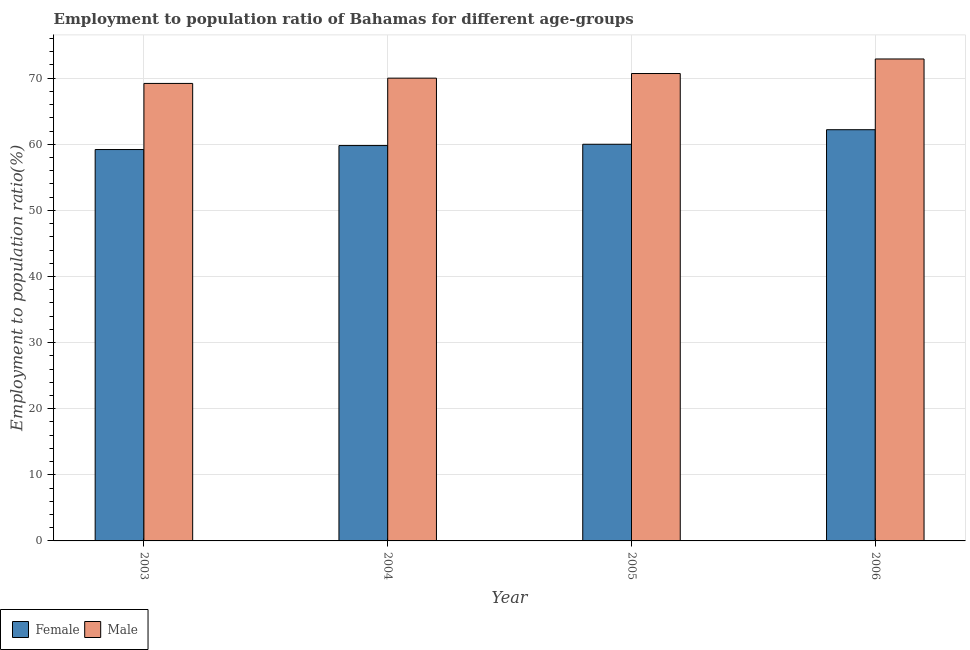Are the number of bars per tick equal to the number of legend labels?
Keep it short and to the point. Yes. Are the number of bars on each tick of the X-axis equal?
Provide a short and direct response. Yes. How many bars are there on the 3rd tick from the left?
Your response must be concise. 2. How many bars are there on the 1st tick from the right?
Provide a short and direct response. 2. What is the employment to population ratio(female) in 2004?
Your answer should be very brief. 59.8. Across all years, what is the maximum employment to population ratio(male)?
Offer a terse response. 72.9. Across all years, what is the minimum employment to population ratio(male)?
Make the answer very short. 69.2. What is the total employment to population ratio(female) in the graph?
Keep it short and to the point. 241.2. What is the difference between the employment to population ratio(female) in 2004 and that in 2005?
Ensure brevity in your answer.  -0.2. What is the difference between the employment to population ratio(male) in 2004 and the employment to population ratio(female) in 2003?
Give a very brief answer. 0.8. What is the average employment to population ratio(female) per year?
Offer a terse response. 60.3. What is the ratio of the employment to population ratio(male) in 2003 to that in 2004?
Offer a very short reply. 0.99. What is the difference between the highest and the second highest employment to population ratio(male)?
Give a very brief answer. 2.2. What is the difference between the highest and the lowest employment to population ratio(male)?
Ensure brevity in your answer.  3.7. In how many years, is the employment to population ratio(male) greater than the average employment to population ratio(male) taken over all years?
Keep it short and to the point. 1. What does the 1st bar from the left in 2004 represents?
Offer a very short reply. Female. How many years are there in the graph?
Your answer should be very brief. 4. Are the values on the major ticks of Y-axis written in scientific E-notation?
Make the answer very short. No. Does the graph contain any zero values?
Your answer should be very brief. No. Where does the legend appear in the graph?
Your answer should be compact. Bottom left. What is the title of the graph?
Make the answer very short. Employment to population ratio of Bahamas for different age-groups. What is the label or title of the X-axis?
Ensure brevity in your answer.  Year. What is the Employment to population ratio(%) of Female in 2003?
Ensure brevity in your answer.  59.2. What is the Employment to population ratio(%) of Male in 2003?
Provide a succinct answer. 69.2. What is the Employment to population ratio(%) in Female in 2004?
Your answer should be very brief. 59.8. What is the Employment to population ratio(%) of Male in 2005?
Keep it short and to the point. 70.7. What is the Employment to population ratio(%) in Female in 2006?
Make the answer very short. 62.2. What is the Employment to population ratio(%) in Male in 2006?
Offer a very short reply. 72.9. Across all years, what is the maximum Employment to population ratio(%) of Female?
Offer a very short reply. 62.2. Across all years, what is the maximum Employment to population ratio(%) of Male?
Offer a terse response. 72.9. Across all years, what is the minimum Employment to population ratio(%) of Female?
Keep it short and to the point. 59.2. Across all years, what is the minimum Employment to population ratio(%) in Male?
Make the answer very short. 69.2. What is the total Employment to population ratio(%) of Female in the graph?
Ensure brevity in your answer.  241.2. What is the total Employment to population ratio(%) of Male in the graph?
Offer a very short reply. 282.8. What is the difference between the Employment to population ratio(%) in Male in 2003 and that in 2005?
Provide a short and direct response. -1.5. What is the difference between the Employment to population ratio(%) of Female in 2004 and that in 2006?
Your answer should be very brief. -2.4. What is the difference between the Employment to population ratio(%) in Female in 2003 and the Employment to population ratio(%) in Male in 2006?
Give a very brief answer. -13.7. What is the difference between the Employment to population ratio(%) of Female in 2004 and the Employment to population ratio(%) of Male in 2005?
Your answer should be very brief. -10.9. What is the average Employment to population ratio(%) of Female per year?
Give a very brief answer. 60.3. What is the average Employment to population ratio(%) in Male per year?
Offer a very short reply. 70.7. In the year 2006, what is the difference between the Employment to population ratio(%) in Female and Employment to population ratio(%) in Male?
Your answer should be compact. -10.7. What is the ratio of the Employment to population ratio(%) of Female in 2003 to that in 2004?
Offer a terse response. 0.99. What is the ratio of the Employment to population ratio(%) in Male in 2003 to that in 2004?
Offer a very short reply. 0.99. What is the ratio of the Employment to population ratio(%) in Female in 2003 to that in 2005?
Make the answer very short. 0.99. What is the ratio of the Employment to population ratio(%) of Male in 2003 to that in 2005?
Keep it short and to the point. 0.98. What is the ratio of the Employment to population ratio(%) of Female in 2003 to that in 2006?
Your answer should be very brief. 0.95. What is the ratio of the Employment to population ratio(%) of Male in 2003 to that in 2006?
Make the answer very short. 0.95. What is the ratio of the Employment to population ratio(%) in Female in 2004 to that in 2006?
Your answer should be very brief. 0.96. What is the ratio of the Employment to population ratio(%) in Male in 2004 to that in 2006?
Provide a short and direct response. 0.96. What is the ratio of the Employment to population ratio(%) of Female in 2005 to that in 2006?
Offer a terse response. 0.96. What is the ratio of the Employment to population ratio(%) in Male in 2005 to that in 2006?
Keep it short and to the point. 0.97. What is the difference between the highest and the second highest Employment to population ratio(%) in Female?
Offer a terse response. 2.2. 